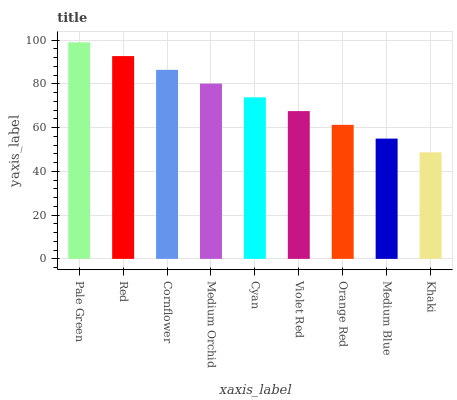Is Khaki the minimum?
Answer yes or no. Yes. Is Pale Green the maximum?
Answer yes or no. Yes. Is Red the minimum?
Answer yes or no. No. Is Red the maximum?
Answer yes or no. No. Is Pale Green greater than Red?
Answer yes or no. Yes. Is Red less than Pale Green?
Answer yes or no. Yes. Is Red greater than Pale Green?
Answer yes or no. No. Is Pale Green less than Red?
Answer yes or no. No. Is Cyan the high median?
Answer yes or no. Yes. Is Cyan the low median?
Answer yes or no. Yes. Is Medium Orchid the high median?
Answer yes or no. No. Is Pale Green the low median?
Answer yes or no. No. 